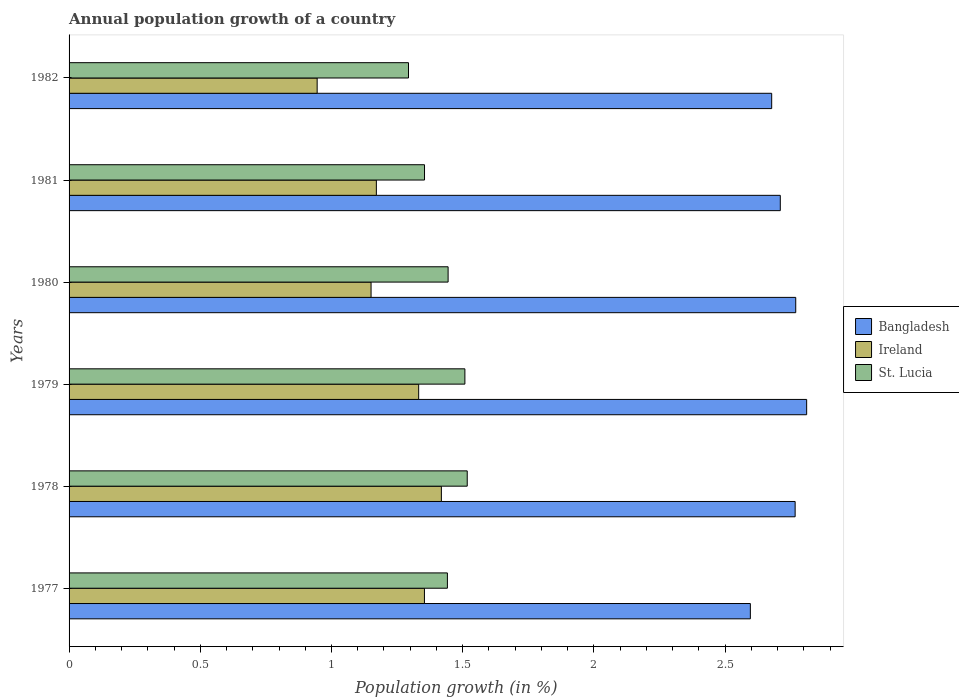How many different coloured bars are there?
Provide a short and direct response. 3. How many groups of bars are there?
Ensure brevity in your answer.  6. Are the number of bars per tick equal to the number of legend labels?
Your answer should be compact. Yes. Are the number of bars on each tick of the Y-axis equal?
Provide a short and direct response. Yes. In how many cases, is the number of bars for a given year not equal to the number of legend labels?
Your answer should be very brief. 0. What is the annual population growth in Ireland in 1979?
Provide a succinct answer. 1.33. Across all years, what is the maximum annual population growth in St. Lucia?
Make the answer very short. 1.52. Across all years, what is the minimum annual population growth in St. Lucia?
Make the answer very short. 1.29. In which year was the annual population growth in Bangladesh maximum?
Your answer should be very brief. 1979. What is the total annual population growth in St. Lucia in the graph?
Make the answer very short. 8.56. What is the difference between the annual population growth in Bangladesh in 1980 and that in 1981?
Make the answer very short. 0.06. What is the difference between the annual population growth in Ireland in 1981 and the annual population growth in St. Lucia in 1978?
Ensure brevity in your answer.  -0.35. What is the average annual population growth in Ireland per year?
Provide a short and direct response. 1.23. In the year 1982, what is the difference between the annual population growth in Bangladesh and annual population growth in St. Lucia?
Your answer should be compact. 1.38. What is the ratio of the annual population growth in Ireland in 1977 to that in 1979?
Your response must be concise. 1.02. What is the difference between the highest and the second highest annual population growth in Ireland?
Provide a succinct answer. 0.06. What is the difference between the highest and the lowest annual population growth in Bangladesh?
Make the answer very short. 0.21. What does the 2nd bar from the top in 1977 represents?
Your answer should be compact. Ireland. How many years are there in the graph?
Provide a succinct answer. 6. Are the values on the major ticks of X-axis written in scientific E-notation?
Keep it short and to the point. No. Does the graph contain any zero values?
Make the answer very short. No. Does the graph contain grids?
Your answer should be very brief. No. Where does the legend appear in the graph?
Ensure brevity in your answer.  Center right. How many legend labels are there?
Make the answer very short. 3. What is the title of the graph?
Provide a succinct answer. Annual population growth of a country. Does "Heavily indebted poor countries" appear as one of the legend labels in the graph?
Give a very brief answer. No. What is the label or title of the X-axis?
Ensure brevity in your answer.  Population growth (in %). What is the Population growth (in %) of Bangladesh in 1977?
Provide a short and direct response. 2.6. What is the Population growth (in %) of Ireland in 1977?
Keep it short and to the point. 1.35. What is the Population growth (in %) in St. Lucia in 1977?
Make the answer very short. 1.44. What is the Population growth (in %) of Bangladesh in 1978?
Offer a very short reply. 2.77. What is the Population growth (in %) in Ireland in 1978?
Your answer should be compact. 1.42. What is the Population growth (in %) in St. Lucia in 1978?
Your answer should be very brief. 1.52. What is the Population growth (in %) of Bangladesh in 1979?
Your answer should be compact. 2.81. What is the Population growth (in %) in Ireland in 1979?
Your answer should be very brief. 1.33. What is the Population growth (in %) of St. Lucia in 1979?
Offer a very short reply. 1.51. What is the Population growth (in %) of Bangladesh in 1980?
Make the answer very short. 2.77. What is the Population growth (in %) of Ireland in 1980?
Your answer should be very brief. 1.15. What is the Population growth (in %) in St. Lucia in 1980?
Provide a succinct answer. 1.44. What is the Population growth (in %) of Bangladesh in 1981?
Make the answer very short. 2.71. What is the Population growth (in %) in Ireland in 1981?
Make the answer very short. 1.17. What is the Population growth (in %) of St. Lucia in 1981?
Make the answer very short. 1.35. What is the Population growth (in %) in Bangladesh in 1982?
Provide a succinct answer. 2.68. What is the Population growth (in %) of Ireland in 1982?
Ensure brevity in your answer.  0.95. What is the Population growth (in %) in St. Lucia in 1982?
Your answer should be compact. 1.29. Across all years, what is the maximum Population growth (in %) of Bangladesh?
Give a very brief answer. 2.81. Across all years, what is the maximum Population growth (in %) in Ireland?
Your answer should be very brief. 1.42. Across all years, what is the maximum Population growth (in %) in St. Lucia?
Give a very brief answer. 1.52. Across all years, what is the minimum Population growth (in %) in Bangladesh?
Offer a very short reply. 2.6. Across all years, what is the minimum Population growth (in %) of Ireland?
Offer a terse response. 0.95. Across all years, what is the minimum Population growth (in %) of St. Lucia?
Give a very brief answer. 1.29. What is the total Population growth (in %) of Bangladesh in the graph?
Your response must be concise. 16.33. What is the total Population growth (in %) in Ireland in the graph?
Your answer should be very brief. 7.37. What is the total Population growth (in %) in St. Lucia in the graph?
Keep it short and to the point. 8.56. What is the difference between the Population growth (in %) in Bangladesh in 1977 and that in 1978?
Offer a terse response. -0.17. What is the difference between the Population growth (in %) in Ireland in 1977 and that in 1978?
Give a very brief answer. -0.06. What is the difference between the Population growth (in %) of St. Lucia in 1977 and that in 1978?
Your response must be concise. -0.08. What is the difference between the Population growth (in %) of Bangladesh in 1977 and that in 1979?
Ensure brevity in your answer.  -0.21. What is the difference between the Population growth (in %) in Ireland in 1977 and that in 1979?
Keep it short and to the point. 0.02. What is the difference between the Population growth (in %) in St. Lucia in 1977 and that in 1979?
Your answer should be very brief. -0.07. What is the difference between the Population growth (in %) in Bangladesh in 1977 and that in 1980?
Provide a short and direct response. -0.17. What is the difference between the Population growth (in %) in Ireland in 1977 and that in 1980?
Offer a very short reply. 0.2. What is the difference between the Population growth (in %) of St. Lucia in 1977 and that in 1980?
Give a very brief answer. -0. What is the difference between the Population growth (in %) in Bangladesh in 1977 and that in 1981?
Keep it short and to the point. -0.11. What is the difference between the Population growth (in %) of Ireland in 1977 and that in 1981?
Your answer should be compact. 0.18. What is the difference between the Population growth (in %) in St. Lucia in 1977 and that in 1981?
Provide a short and direct response. 0.09. What is the difference between the Population growth (in %) in Bangladesh in 1977 and that in 1982?
Provide a short and direct response. -0.08. What is the difference between the Population growth (in %) of Ireland in 1977 and that in 1982?
Ensure brevity in your answer.  0.41. What is the difference between the Population growth (in %) of St. Lucia in 1977 and that in 1982?
Give a very brief answer. 0.15. What is the difference between the Population growth (in %) in Bangladesh in 1978 and that in 1979?
Offer a terse response. -0.04. What is the difference between the Population growth (in %) in Ireland in 1978 and that in 1979?
Your answer should be compact. 0.09. What is the difference between the Population growth (in %) in St. Lucia in 1978 and that in 1979?
Provide a succinct answer. 0.01. What is the difference between the Population growth (in %) of Bangladesh in 1978 and that in 1980?
Give a very brief answer. -0. What is the difference between the Population growth (in %) of Ireland in 1978 and that in 1980?
Provide a short and direct response. 0.27. What is the difference between the Population growth (in %) of St. Lucia in 1978 and that in 1980?
Make the answer very short. 0.07. What is the difference between the Population growth (in %) in Bangladesh in 1978 and that in 1981?
Provide a succinct answer. 0.06. What is the difference between the Population growth (in %) of Ireland in 1978 and that in 1981?
Make the answer very short. 0.25. What is the difference between the Population growth (in %) of St. Lucia in 1978 and that in 1981?
Ensure brevity in your answer.  0.16. What is the difference between the Population growth (in %) of Bangladesh in 1978 and that in 1982?
Keep it short and to the point. 0.09. What is the difference between the Population growth (in %) in Ireland in 1978 and that in 1982?
Provide a succinct answer. 0.47. What is the difference between the Population growth (in %) in St. Lucia in 1978 and that in 1982?
Give a very brief answer. 0.22. What is the difference between the Population growth (in %) of Bangladesh in 1979 and that in 1980?
Provide a short and direct response. 0.04. What is the difference between the Population growth (in %) of Ireland in 1979 and that in 1980?
Give a very brief answer. 0.18. What is the difference between the Population growth (in %) in St. Lucia in 1979 and that in 1980?
Make the answer very short. 0.06. What is the difference between the Population growth (in %) of Bangladesh in 1979 and that in 1981?
Give a very brief answer. 0.1. What is the difference between the Population growth (in %) of Ireland in 1979 and that in 1981?
Provide a short and direct response. 0.16. What is the difference between the Population growth (in %) of St. Lucia in 1979 and that in 1981?
Offer a very short reply. 0.15. What is the difference between the Population growth (in %) in Bangladesh in 1979 and that in 1982?
Offer a terse response. 0.13. What is the difference between the Population growth (in %) of Ireland in 1979 and that in 1982?
Your response must be concise. 0.39. What is the difference between the Population growth (in %) in St. Lucia in 1979 and that in 1982?
Give a very brief answer. 0.21. What is the difference between the Population growth (in %) of Bangladesh in 1980 and that in 1981?
Ensure brevity in your answer.  0.06. What is the difference between the Population growth (in %) in Ireland in 1980 and that in 1981?
Ensure brevity in your answer.  -0.02. What is the difference between the Population growth (in %) in St. Lucia in 1980 and that in 1981?
Make the answer very short. 0.09. What is the difference between the Population growth (in %) of Bangladesh in 1980 and that in 1982?
Offer a very short reply. 0.09. What is the difference between the Population growth (in %) of Ireland in 1980 and that in 1982?
Make the answer very short. 0.21. What is the difference between the Population growth (in %) of St. Lucia in 1980 and that in 1982?
Your answer should be compact. 0.15. What is the difference between the Population growth (in %) in Bangladesh in 1981 and that in 1982?
Offer a very short reply. 0.03. What is the difference between the Population growth (in %) in Ireland in 1981 and that in 1982?
Your answer should be very brief. 0.23. What is the difference between the Population growth (in %) of St. Lucia in 1981 and that in 1982?
Your answer should be very brief. 0.06. What is the difference between the Population growth (in %) in Bangladesh in 1977 and the Population growth (in %) in Ireland in 1978?
Your answer should be compact. 1.18. What is the difference between the Population growth (in %) in Bangladesh in 1977 and the Population growth (in %) in St. Lucia in 1978?
Offer a terse response. 1.08. What is the difference between the Population growth (in %) in Ireland in 1977 and the Population growth (in %) in St. Lucia in 1978?
Give a very brief answer. -0.16. What is the difference between the Population growth (in %) of Bangladesh in 1977 and the Population growth (in %) of Ireland in 1979?
Give a very brief answer. 1.26. What is the difference between the Population growth (in %) in Bangladesh in 1977 and the Population growth (in %) in St. Lucia in 1979?
Ensure brevity in your answer.  1.09. What is the difference between the Population growth (in %) of Ireland in 1977 and the Population growth (in %) of St. Lucia in 1979?
Your answer should be very brief. -0.15. What is the difference between the Population growth (in %) of Bangladesh in 1977 and the Population growth (in %) of Ireland in 1980?
Offer a terse response. 1.45. What is the difference between the Population growth (in %) in Bangladesh in 1977 and the Population growth (in %) in St. Lucia in 1980?
Ensure brevity in your answer.  1.15. What is the difference between the Population growth (in %) in Ireland in 1977 and the Population growth (in %) in St. Lucia in 1980?
Your answer should be very brief. -0.09. What is the difference between the Population growth (in %) in Bangladesh in 1977 and the Population growth (in %) in Ireland in 1981?
Give a very brief answer. 1.43. What is the difference between the Population growth (in %) of Bangladesh in 1977 and the Population growth (in %) of St. Lucia in 1981?
Make the answer very short. 1.24. What is the difference between the Population growth (in %) in Ireland in 1977 and the Population growth (in %) in St. Lucia in 1981?
Give a very brief answer. -0. What is the difference between the Population growth (in %) in Bangladesh in 1977 and the Population growth (in %) in Ireland in 1982?
Keep it short and to the point. 1.65. What is the difference between the Population growth (in %) of Bangladesh in 1977 and the Population growth (in %) of St. Lucia in 1982?
Offer a terse response. 1.3. What is the difference between the Population growth (in %) in Ireland in 1977 and the Population growth (in %) in St. Lucia in 1982?
Your response must be concise. 0.06. What is the difference between the Population growth (in %) of Bangladesh in 1978 and the Population growth (in %) of Ireland in 1979?
Provide a short and direct response. 1.43. What is the difference between the Population growth (in %) in Bangladesh in 1978 and the Population growth (in %) in St. Lucia in 1979?
Provide a short and direct response. 1.26. What is the difference between the Population growth (in %) in Ireland in 1978 and the Population growth (in %) in St. Lucia in 1979?
Ensure brevity in your answer.  -0.09. What is the difference between the Population growth (in %) in Bangladesh in 1978 and the Population growth (in %) in Ireland in 1980?
Offer a terse response. 1.62. What is the difference between the Population growth (in %) in Bangladesh in 1978 and the Population growth (in %) in St. Lucia in 1980?
Give a very brief answer. 1.32. What is the difference between the Population growth (in %) of Ireland in 1978 and the Population growth (in %) of St. Lucia in 1980?
Ensure brevity in your answer.  -0.03. What is the difference between the Population growth (in %) in Bangladesh in 1978 and the Population growth (in %) in Ireland in 1981?
Your answer should be compact. 1.6. What is the difference between the Population growth (in %) of Bangladesh in 1978 and the Population growth (in %) of St. Lucia in 1981?
Keep it short and to the point. 1.41. What is the difference between the Population growth (in %) in Ireland in 1978 and the Population growth (in %) in St. Lucia in 1981?
Your answer should be compact. 0.06. What is the difference between the Population growth (in %) of Bangladesh in 1978 and the Population growth (in %) of Ireland in 1982?
Keep it short and to the point. 1.82. What is the difference between the Population growth (in %) of Bangladesh in 1978 and the Population growth (in %) of St. Lucia in 1982?
Offer a very short reply. 1.47. What is the difference between the Population growth (in %) in Ireland in 1978 and the Population growth (in %) in St. Lucia in 1982?
Your answer should be very brief. 0.13. What is the difference between the Population growth (in %) in Bangladesh in 1979 and the Population growth (in %) in Ireland in 1980?
Offer a terse response. 1.66. What is the difference between the Population growth (in %) in Bangladesh in 1979 and the Population growth (in %) in St. Lucia in 1980?
Provide a succinct answer. 1.37. What is the difference between the Population growth (in %) in Ireland in 1979 and the Population growth (in %) in St. Lucia in 1980?
Provide a short and direct response. -0.11. What is the difference between the Population growth (in %) of Bangladesh in 1979 and the Population growth (in %) of Ireland in 1981?
Give a very brief answer. 1.64. What is the difference between the Population growth (in %) of Bangladesh in 1979 and the Population growth (in %) of St. Lucia in 1981?
Provide a short and direct response. 1.46. What is the difference between the Population growth (in %) in Ireland in 1979 and the Population growth (in %) in St. Lucia in 1981?
Ensure brevity in your answer.  -0.02. What is the difference between the Population growth (in %) in Bangladesh in 1979 and the Population growth (in %) in Ireland in 1982?
Your response must be concise. 1.87. What is the difference between the Population growth (in %) in Bangladesh in 1979 and the Population growth (in %) in St. Lucia in 1982?
Make the answer very short. 1.52. What is the difference between the Population growth (in %) in Ireland in 1979 and the Population growth (in %) in St. Lucia in 1982?
Your answer should be compact. 0.04. What is the difference between the Population growth (in %) in Bangladesh in 1980 and the Population growth (in %) in Ireland in 1981?
Your response must be concise. 1.6. What is the difference between the Population growth (in %) in Bangladesh in 1980 and the Population growth (in %) in St. Lucia in 1981?
Offer a terse response. 1.41. What is the difference between the Population growth (in %) of Ireland in 1980 and the Population growth (in %) of St. Lucia in 1981?
Provide a short and direct response. -0.2. What is the difference between the Population growth (in %) in Bangladesh in 1980 and the Population growth (in %) in Ireland in 1982?
Make the answer very short. 1.82. What is the difference between the Population growth (in %) in Bangladesh in 1980 and the Population growth (in %) in St. Lucia in 1982?
Your answer should be compact. 1.48. What is the difference between the Population growth (in %) of Ireland in 1980 and the Population growth (in %) of St. Lucia in 1982?
Provide a short and direct response. -0.14. What is the difference between the Population growth (in %) of Bangladesh in 1981 and the Population growth (in %) of Ireland in 1982?
Offer a terse response. 1.76. What is the difference between the Population growth (in %) in Bangladesh in 1981 and the Population growth (in %) in St. Lucia in 1982?
Make the answer very short. 1.42. What is the difference between the Population growth (in %) in Ireland in 1981 and the Population growth (in %) in St. Lucia in 1982?
Offer a terse response. -0.12. What is the average Population growth (in %) in Bangladesh per year?
Provide a succinct answer. 2.72. What is the average Population growth (in %) in Ireland per year?
Keep it short and to the point. 1.23. What is the average Population growth (in %) of St. Lucia per year?
Ensure brevity in your answer.  1.43. In the year 1977, what is the difference between the Population growth (in %) in Bangladesh and Population growth (in %) in Ireland?
Give a very brief answer. 1.24. In the year 1977, what is the difference between the Population growth (in %) in Bangladesh and Population growth (in %) in St. Lucia?
Your response must be concise. 1.15. In the year 1977, what is the difference between the Population growth (in %) in Ireland and Population growth (in %) in St. Lucia?
Offer a terse response. -0.09. In the year 1978, what is the difference between the Population growth (in %) of Bangladesh and Population growth (in %) of Ireland?
Offer a terse response. 1.35. In the year 1978, what is the difference between the Population growth (in %) in Bangladesh and Population growth (in %) in St. Lucia?
Provide a succinct answer. 1.25. In the year 1978, what is the difference between the Population growth (in %) of Ireland and Population growth (in %) of St. Lucia?
Keep it short and to the point. -0.1. In the year 1979, what is the difference between the Population growth (in %) in Bangladesh and Population growth (in %) in Ireland?
Your response must be concise. 1.48. In the year 1979, what is the difference between the Population growth (in %) in Bangladesh and Population growth (in %) in St. Lucia?
Provide a short and direct response. 1.3. In the year 1979, what is the difference between the Population growth (in %) of Ireland and Population growth (in %) of St. Lucia?
Keep it short and to the point. -0.18. In the year 1980, what is the difference between the Population growth (in %) in Bangladesh and Population growth (in %) in Ireland?
Give a very brief answer. 1.62. In the year 1980, what is the difference between the Population growth (in %) in Bangladesh and Population growth (in %) in St. Lucia?
Offer a very short reply. 1.32. In the year 1980, what is the difference between the Population growth (in %) of Ireland and Population growth (in %) of St. Lucia?
Your response must be concise. -0.29. In the year 1981, what is the difference between the Population growth (in %) in Bangladesh and Population growth (in %) in Ireland?
Provide a succinct answer. 1.54. In the year 1981, what is the difference between the Population growth (in %) in Bangladesh and Population growth (in %) in St. Lucia?
Your answer should be compact. 1.36. In the year 1981, what is the difference between the Population growth (in %) of Ireland and Population growth (in %) of St. Lucia?
Keep it short and to the point. -0.18. In the year 1982, what is the difference between the Population growth (in %) of Bangladesh and Population growth (in %) of Ireland?
Ensure brevity in your answer.  1.73. In the year 1982, what is the difference between the Population growth (in %) in Bangladesh and Population growth (in %) in St. Lucia?
Offer a very short reply. 1.38. In the year 1982, what is the difference between the Population growth (in %) in Ireland and Population growth (in %) in St. Lucia?
Offer a very short reply. -0.35. What is the ratio of the Population growth (in %) of Bangladesh in 1977 to that in 1978?
Provide a short and direct response. 0.94. What is the ratio of the Population growth (in %) of Ireland in 1977 to that in 1978?
Make the answer very short. 0.95. What is the ratio of the Population growth (in %) in St. Lucia in 1977 to that in 1978?
Provide a succinct answer. 0.95. What is the ratio of the Population growth (in %) in Bangladesh in 1977 to that in 1979?
Your answer should be very brief. 0.92. What is the ratio of the Population growth (in %) in Ireland in 1977 to that in 1979?
Your answer should be compact. 1.02. What is the ratio of the Population growth (in %) of St. Lucia in 1977 to that in 1979?
Keep it short and to the point. 0.96. What is the ratio of the Population growth (in %) of Bangladesh in 1977 to that in 1980?
Offer a terse response. 0.94. What is the ratio of the Population growth (in %) of Ireland in 1977 to that in 1980?
Give a very brief answer. 1.18. What is the ratio of the Population growth (in %) in St. Lucia in 1977 to that in 1980?
Your answer should be very brief. 1. What is the ratio of the Population growth (in %) in Bangladesh in 1977 to that in 1981?
Ensure brevity in your answer.  0.96. What is the ratio of the Population growth (in %) of Ireland in 1977 to that in 1981?
Your answer should be very brief. 1.16. What is the ratio of the Population growth (in %) in St. Lucia in 1977 to that in 1981?
Provide a succinct answer. 1.06. What is the ratio of the Population growth (in %) of Bangladesh in 1977 to that in 1982?
Give a very brief answer. 0.97. What is the ratio of the Population growth (in %) in Ireland in 1977 to that in 1982?
Your answer should be compact. 1.43. What is the ratio of the Population growth (in %) in St. Lucia in 1977 to that in 1982?
Provide a short and direct response. 1.11. What is the ratio of the Population growth (in %) of Bangladesh in 1978 to that in 1979?
Offer a terse response. 0.98. What is the ratio of the Population growth (in %) in Ireland in 1978 to that in 1979?
Offer a terse response. 1.06. What is the ratio of the Population growth (in %) of St. Lucia in 1978 to that in 1979?
Your answer should be very brief. 1.01. What is the ratio of the Population growth (in %) of Bangladesh in 1978 to that in 1980?
Provide a succinct answer. 1. What is the ratio of the Population growth (in %) in Ireland in 1978 to that in 1980?
Offer a very short reply. 1.23. What is the ratio of the Population growth (in %) of St. Lucia in 1978 to that in 1980?
Your answer should be very brief. 1.05. What is the ratio of the Population growth (in %) of Bangladesh in 1978 to that in 1981?
Give a very brief answer. 1.02. What is the ratio of the Population growth (in %) of Ireland in 1978 to that in 1981?
Make the answer very short. 1.21. What is the ratio of the Population growth (in %) in St. Lucia in 1978 to that in 1981?
Offer a very short reply. 1.12. What is the ratio of the Population growth (in %) of Bangladesh in 1978 to that in 1982?
Ensure brevity in your answer.  1.03. What is the ratio of the Population growth (in %) in Ireland in 1978 to that in 1982?
Keep it short and to the point. 1.5. What is the ratio of the Population growth (in %) of St. Lucia in 1978 to that in 1982?
Your answer should be compact. 1.17. What is the ratio of the Population growth (in %) in Bangladesh in 1979 to that in 1980?
Provide a short and direct response. 1.01. What is the ratio of the Population growth (in %) of Ireland in 1979 to that in 1980?
Ensure brevity in your answer.  1.16. What is the ratio of the Population growth (in %) in St. Lucia in 1979 to that in 1980?
Give a very brief answer. 1.04. What is the ratio of the Population growth (in %) in Bangladesh in 1979 to that in 1981?
Give a very brief answer. 1.04. What is the ratio of the Population growth (in %) in Ireland in 1979 to that in 1981?
Your answer should be very brief. 1.14. What is the ratio of the Population growth (in %) in St. Lucia in 1979 to that in 1981?
Your answer should be very brief. 1.11. What is the ratio of the Population growth (in %) in Bangladesh in 1979 to that in 1982?
Offer a terse response. 1.05. What is the ratio of the Population growth (in %) in Ireland in 1979 to that in 1982?
Make the answer very short. 1.41. What is the ratio of the Population growth (in %) of St. Lucia in 1979 to that in 1982?
Your response must be concise. 1.17. What is the ratio of the Population growth (in %) in Bangladesh in 1980 to that in 1981?
Provide a succinct answer. 1.02. What is the ratio of the Population growth (in %) in Ireland in 1980 to that in 1981?
Make the answer very short. 0.98. What is the ratio of the Population growth (in %) of St. Lucia in 1980 to that in 1981?
Keep it short and to the point. 1.07. What is the ratio of the Population growth (in %) in Bangladesh in 1980 to that in 1982?
Ensure brevity in your answer.  1.03. What is the ratio of the Population growth (in %) in Ireland in 1980 to that in 1982?
Offer a terse response. 1.22. What is the ratio of the Population growth (in %) in St. Lucia in 1980 to that in 1982?
Provide a succinct answer. 1.12. What is the ratio of the Population growth (in %) in Bangladesh in 1981 to that in 1982?
Provide a succinct answer. 1.01. What is the ratio of the Population growth (in %) in Ireland in 1981 to that in 1982?
Provide a succinct answer. 1.24. What is the ratio of the Population growth (in %) in St. Lucia in 1981 to that in 1982?
Give a very brief answer. 1.05. What is the difference between the highest and the second highest Population growth (in %) in Bangladesh?
Offer a terse response. 0.04. What is the difference between the highest and the second highest Population growth (in %) in Ireland?
Make the answer very short. 0.06. What is the difference between the highest and the second highest Population growth (in %) in St. Lucia?
Ensure brevity in your answer.  0.01. What is the difference between the highest and the lowest Population growth (in %) of Bangladesh?
Your answer should be compact. 0.21. What is the difference between the highest and the lowest Population growth (in %) in Ireland?
Ensure brevity in your answer.  0.47. What is the difference between the highest and the lowest Population growth (in %) in St. Lucia?
Offer a terse response. 0.22. 